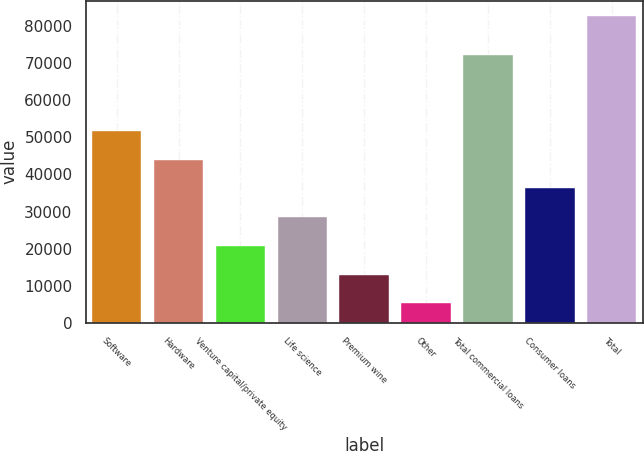Convert chart to OTSL. <chart><loc_0><loc_0><loc_500><loc_500><bar_chart><fcel>Software<fcel>Hardware<fcel>Venture capital/private equity<fcel>Life science<fcel>Premium wine<fcel>Other<fcel>Total commercial loans<fcel>Consumer loans<fcel>Total<nl><fcel>51703.4<fcel>43972.5<fcel>20779.8<fcel>28510.7<fcel>13048.9<fcel>5318<fcel>72104<fcel>36241.6<fcel>82627<nl></chart> 